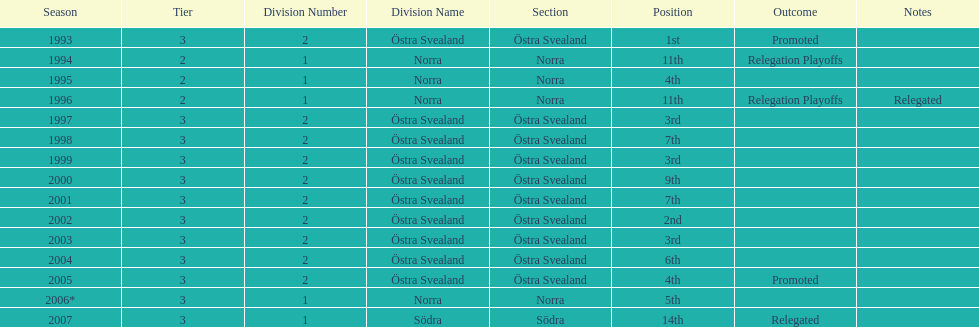What section did they play in the most? Östra Svealand. Would you mind parsing the complete table? {'header': ['Season', 'Tier', 'Division Number', 'Division Name', 'Section', 'Position', 'Outcome', 'Notes'], 'rows': [['1993', '3', '2', 'Östra Svealand', 'Östra Svealand', '1st', 'Promoted', ''], ['1994', '2', '1', 'Norra', 'Norra', '11th', 'Relegation Playoffs', ''], ['1995', '2', '1', 'Norra', 'Norra', '4th', '', ''], ['1996', '2', '1', 'Norra', 'Norra', '11th', 'Relegation Playoffs', 'Relegated'], ['1997', '3', '2', 'Östra Svealand', 'Östra Svealand', '3rd', '', ''], ['1998', '3', '2', 'Östra Svealand', 'Östra Svealand', '7th', '', ''], ['1999', '3', '2', 'Östra Svealand', 'Östra Svealand', '3rd', '', ''], ['2000', '3', '2', 'Östra Svealand', 'Östra Svealand', '9th', '', ''], ['2001', '3', '2', 'Östra Svealand', 'Östra Svealand', '7th', '', ''], ['2002', '3', '2', 'Östra Svealand', 'Östra Svealand', '2nd', '', ''], ['2003', '3', '2', 'Östra Svealand', 'Östra Svealand', '3rd', '', ''], ['2004', '3', '2', 'Östra Svealand', 'Östra Svealand', '6th', '', ''], ['2005', '3', '2', 'Östra Svealand', 'Östra Svealand', '4th', 'Promoted', ''], ['2006*', '3', '1', 'Norra', 'Norra', '5th', '', ''], ['2007', '3', '1', 'Södra', 'Södra', '14th', 'Relegated', '']]} 